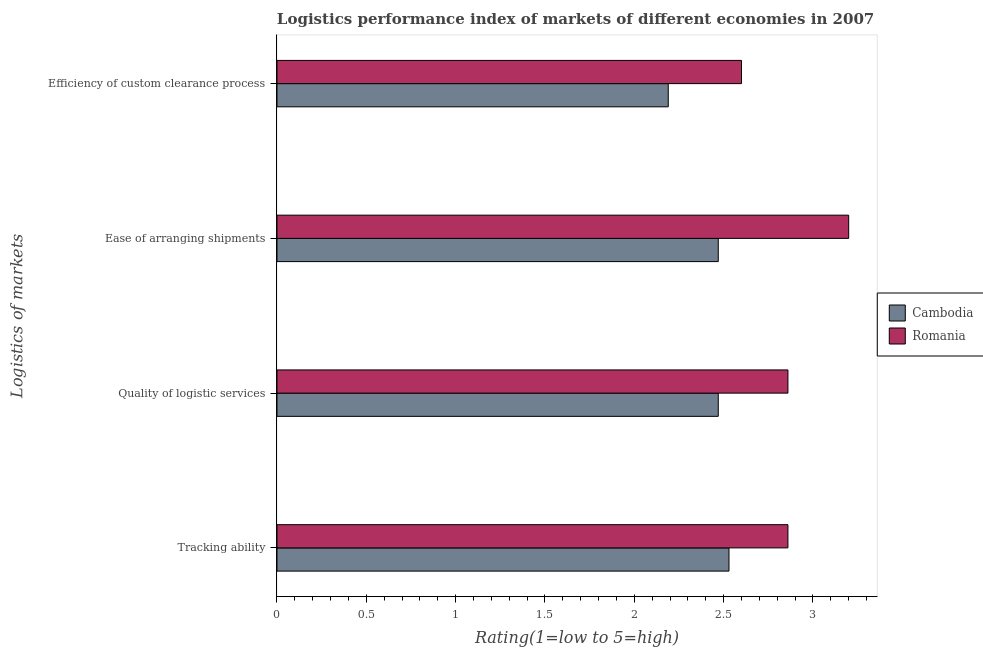How many different coloured bars are there?
Offer a very short reply. 2. How many groups of bars are there?
Offer a terse response. 4. Are the number of bars on each tick of the Y-axis equal?
Your answer should be very brief. Yes. How many bars are there on the 4th tick from the top?
Offer a very short reply. 2. What is the label of the 4th group of bars from the top?
Give a very brief answer. Tracking ability. What is the lpi rating of efficiency of custom clearance process in Cambodia?
Provide a succinct answer. 2.19. Across all countries, what is the minimum lpi rating of efficiency of custom clearance process?
Offer a terse response. 2.19. In which country was the lpi rating of efficiency of custom clearance process maximum?
Offer a very short reply. Romania. In which country was the lpi rating of ease of arranging shipments minimum?
Your answer should be compact. Cambodia. What is the total lpi rating of efficiency of custom clearance process in the graph?
Make the answer very short. 4.79. What is the difference between the lpi rating of tracking ability in Romania and that in Cambodia?
Your answer should be very brief. 0.33. What is the difference between the lpi rating of tracking ability in Cambodia and the lpi rating of quality of logistic services in Romania?
Your answer should be compact. -0.33. What is the average lpi rating of quality of logistic services per country?
Make the answer very short. 2.67. What is the difference between the lpi rating of tracking ability and lpi rating of ease of arranging shipments in Romania?
Make the answer very short. -0.34. What is the ratio of the lpi rating of tracking ability in Cambodia to that in Romania?
Provide a succinct answer. 0.88. Is the lpi rating of tracking ability in Cambodia less than that in Romania?
Ensure brevity in your answer.  Yes. What is the difference between the highest and the second highest lpi rating of tracking ability?
Provide a short and direct response. 0.33. What is the difference between the highest and the lowest lpi rating of tracking ability?
Provide a short and direct response. 0.33. Is the sum of the lpi rating of ease of arranging shipments in Romania and Cambodia greater than the maximum lpi rating of quality of logistic services across all countries?
Offer a terse response. Yes. What does the 2nd bar from the top in Quality of logistic services represents?
Offer a very short reply. Cambodia. What does the 1st bar from the bottom in Quality of logistic services represents?
Offer a very short reply. Cambodia. Is it the case that in every country, the sum of the lpi rating of tracking ability and lpi rating of quality of logistic services is greater than the lpi rating of ease of arranging shipments?
Your answer should be very brief. Yes. How many bars are there?
Your answer should be very brief. 8. How many countries are there in the graph?
Your answer should be compact. 2. What is the difference between two consecutive major ticks on the X-axis?
Your answer should be compact. 0.5. Are the values on the major ticks of X-axis written in scientific E-notation?
Ensure brevity in your answer.  No. Does the graph contain any zero values?
Provide a short and direct response. No. Does the graph contain grids?
Your answer should be compact. No. Where does the legend appear in the graph?
Provide a succinct answer. Center right. What is the title of the graph?
Your answer should be compact. Logistics performance index of markets of different economies in 2007. What is the label or title of the X-axis?
Ensure brevity in your answer.  Rating(1=low to 5=high). What is the label or title of the Y-axis?
Make the answer very short. Logistics of markets. What is the Rating(1=low to 5=high) of Cambodia in Tracking ability?
Ensure brevity in your answer.  2.53. What is the Rating(1=low to 5=high) in Romania in Tracking ability?
Your response must be concise. 2.86. What is the Rating(1=low to 5=high) in Cambodia in Quality of logistic services?
Make the answer very short. 2.47. What is the Rating(1=low to 5=high) in Romania in Quality of logistic services?
Your answer should be compact. 2.86. What is the Rating(1=low to 5=high) of Cambodia in Ease of arranging shipments?
Give a very brief answer. 2.47. What is the Rating(1=low to 5=high) of Romania in Ease of arranging shipments?
Offer a terse response. 3.2. What is the Rating(1=low to 5=high) of Cambodia in Efficiency of custom clearance process?
Ensure brevity in your answer.  2.19. What is the Rating(1=low to 5=high) of Romania in Efficiency of custom clearance process?
Make the answer very short. 2.6. Across all Logistics of markets, what is the maximum Rating(1=low to 5=high) of Cambodia?
Provide a succinct answer. 2.53. Across all Logistics of markets, what is the minimum Rating(1=low to 5=high) of Cambodia?
Offer a very short reply. 2.19. What is the total Rating(1=low to 5=high) of Cambodia in the graph?
Offer a terse response. 9.66. What is the total Rating(1=low to 5=high) of Romania in the graph?
Your answer should be very brief. 11.52. What is the difference between the Rating(1=low to 5=high) of Cambodia in Tracking ability and that in Quality of logistic services?
Your answer should be very brief. 0.06. What is the difference between the Rating(1=low to 5=high) of Romania in Tracking ability and that in Ease of arranging shipments?
Make the answer very short. -0.34. What is the difference between the Rating(1=low to 5=high) of Cambodia in Tracking ability and that in Efficiency of custom clearance process?
Your answer should be very brief. 0.34. What is the difference between the Rating(1=low to 5=high) of Romania in Tracking ability and that in Efficiency of custom clearance process?
Your response must be concise. 0.26. What is the difference between the Rating(1=low to 5=high) in Romania in Quality of logistic services and that in Ease of arranging shipments?
Provide a succinct answer. -0.34. What is the difference between the Rating(1=low to 5=high) of Cambodia in Quality of logistic services and that in Efficiency of custom clearance process?
Your answer should be compact. 0.28. What is the difference between the Rating(1=low to 5=high) in Romania in Quality of logistic services and that in Efficiency of custom clearance process?
Offer a terse response. 0.26. What is the difference between the Rating(1=low to 5=high) in Cambodia in Ease of arranging shipments and that in Efficiency of custom clearance process?
Provide a succinct answer. 0.28. What is the difference between the Rating(1=low to 5=high) of Cambodia in Tracking ability and the Rating(1=low to 5=high) of Romania in Quality of logistic services?
Ensure brevity in your answer.  -0.33. What is the difference between the Rating(1=low to 5=high) in Cambodia in Tracking ability and the Rating(1=low to 5=high) in Romania in Ease of arranging shipments?
Your response must be concise. -0.67. What is the difference between the Rating(1=low to 5=high) in Cambodia in Tracking ability and the Rating(1=low to 5=high) in Romania in Efficiency of custom clearance process?
Make the answer very short. -0.07. What is the difference between the Rating(1=low to 5=high) of Cambodia in Quality of logistic services and the Rating(1=low to 5=high) of Romania in Ease of arranging shipments?
Make the answer very short. -0.73. What is the difference between the Rating(1=low to 5=high) in Cambodia in Quality of logistic services and the Rating(1=low to 5=high) in Romania in Efficiency of custom clearance process?
Your answer should be very brief. -0.13. What is the difference between the Rating(1=low to 5=high) of Cambodia in Ease of arranging shipments and the Rating(1=low to 5=high) of Romania in Efficiency of custom clearance process?
Provide a succinct answer. -0.13. What is the average Rating(1=low to 5=high) in Cambodia per Logistics of markets?
Provide a succinct answer. 2.42. What is the average Rating(1=low to 5=high) in Romania per Logistics of markets?
Provide a short and direct response. 2.88. What is the difference between the Rating(1=low to 5=high) in Cambodia and Rating(1=low to 5=high) in Romania in Tracking ability?
Provide a succinct answer. -0.33. What is the difference between the Rating(1=low to 5=high) in Cambodia and Rating(1=low to 5=high) in Romania in Quality of logistic services?
Your response must be concise. -0.39. What is the difference between the Rating(1=low to 5=high) in Cambodia and Rating(1=low to 5=high) in Romania in Ease of arranging shipments?
Offer a terse response. -0.73. What is the difference between the Rating(1=low to 5=high) in Cambodia and Rating(1=low to 5=high) in Romania in Efficiency of custom clearance process?
Your answer should be very brief. -0.41. What is the ratio of the Rating(1=low to 5=high) of Cambodia in Tracking ability to that in Quality of logistic services?
Make the answer very short. 1.02. What is the ratio of the Rating(1=low to 5=high) in Cambodia in Tracking ability to that in Ease of arranging shipments?
Your response must be concise. 1.02. What is the ratio of the Rating(1=low to 5=high) of Romania in Tracking ability to that in Ease of arranging shipments?
Make the answer very short. 0.89. What is the ratio of the Rating(1=low to 5=high) of Cambodia in Tracking ability to that in Efficiency of custom clearance process?
Offer a terse response. 1.16. What is the ratio of the Rating(1=low to 5=high) of Romania in Quality of logistic services to that in Ease of arranging shipments?
Ensure brevity in your answer.  0.89. What is the ratio of the Rating(1=low to 5=high) of Cambodia in Quality of logistic services to that in Efficiency of custom clearance process?
Offer a terse response. 1.13. What is the ratio of the Rating(1=low to 5=high) in Romania in Quality of logistic services to that in Efficiency of custom clearance process?
Make the answer very short. 1.1. What is the ratio of the Rating(1=low to 5=high) of Cambodia in Ease of arranging shipments to that in Efficiency of custom clearance process?
Your answer should be very brief. 1.13. What is the ratio of the Rating(1=low to 5=high) in Romania in Ease of arranging shipments to that in Efficiency of custom clearance process?
Offer a very short reply. 1.23. What is the difference between the highest and the second highest Rating(1=low to 5=high) of Romania?
Your response must be concise. 0.34. What is the difference between the highest and the lowest Rating(1=low to 5=high) of Cambodia?
Your response must be concise. 0.34. What is the difference between the highest and the lowest Rating(1=low to 5=high) of Romania?
Provide a short and direct response. 0.6. 